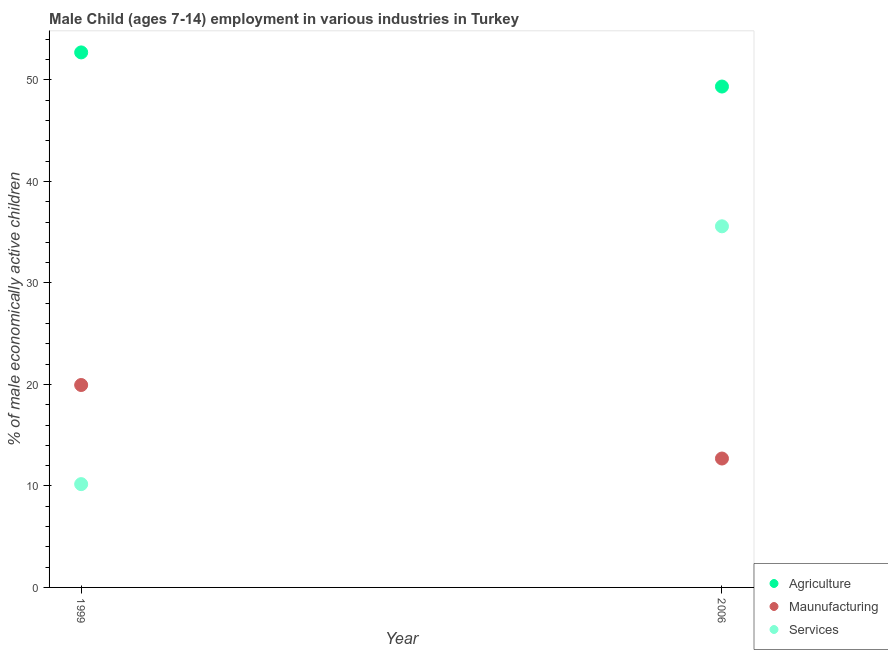How many different coloured dotlines are there?
Make the answer very short. 3. Is the number of dotlines equal to the number of legend labels?
Your answer should be compact. Yes. What is the percentage of economically active children in manufacturing in 1999?
Ensure brevity in your answer.  19.94. Across all years, what is the maximum percentage of economically active children in manufacturing?
Give a very brief answer. 19.94. Across all years, what is the minimum percentage of economically active children in agriculture?
Provide a succinct answer. 49.35. In which year was the percentage of economically active children in services maximum?
Your answer should be compact. 2006. What is the total percentage of economically active children in services in the graph?
Your answer should be very brief. 45.76. What is the difference between the percentage of economically active children in services in 1999 and that in 2006?
Make the answer very short. -25.4. What is the difference between the percentage of economically active children in manufacturing in 2006 and the percentage of economically active children in agriculture in 1999?
Give a very brief answer. -40.01. What is the average percentage of economically active children in services per year?
Your answer should be very brief. 22.88. In the year 2006, what is the difference between the percentage of economically active children in manufacturing and percentage of economically active children in agriculture?
Ensure brevity in your answer.  -36.65. In how many years, is the percentage of economically active children in services greater than 2 %?
Offer a very short reply. 2. What is the ratio of the percentage of economically active children in services in 1999 to that in 2006?
Ensure brevity in your answer.  0.29. Is it the case that in every year, the sum of the percentage of economically active children in agriculture and percentage of economically active children in manufacturing is greater than the percentage of economically active children in services?
Provide a succinct answer. Yes. Is the percentage of economically active children in manufacturing strictly greater than the percentage of economically active children in services over the years?
Offer a very short reply. No. Is the percentage of economically active children in agriculture strictly less than the percentage of economically active children in manufacturing over the years?
Provide a short and direct response. No. How many years are there in the graph?
Your answer should be very brief. 2. Are the values on the major ticks of Y-axis written in scientific E-notation?
Offer a terse response. No. Does the graph contain any zero values?
Give a very brief answer. No. Where does the legend appear in the graph?
Your response must be concise. Bottom right. What is the title of the graph?
Offer a very short reply. Male Child (ages 7-14) employment in various industries in Turkey. What is the label or title of the X-axis?
Give a very brief answer. Year. What is the label or title of the Y-axis?
Offer a very short reply. % of male economically active children. What is the % of male economically active children of Agriculture in 1999?
Make the answer very short. 52.71. What is the % of male economically active children of Maunufacturing in 1999?
Give a very brief answer. 19.94. What is the % of male economically active children of Services in 1999?
Provide a succinct answer. 10.18. What is the % of male economically active children of Agriculture in 2006?
Make the answer very short. 49.35. What is the % of male economically active children of Services in 2006?
Offer a very short reply. 35.58. Across all years, what is the maximum % of male economically active children of Agriculture?
Keep it short and to the point. 52.71. Across all years, what is the maximum % of male economically active children of Maunufacturing?
Ensure brevity in your answer.  19.94. Across all years, what is the maximum % of male economically active children in Services?
Offer a terse response. 35.58. Across all years, what is the minimum % of male economically active children of Agriculture?
Your answer should be compact. 49.35. Across all years, what is the minimum % of male economically active children in Services?
Your answer should be compact. 10.18. What is the total % of male economically active children in Agriculture in the graph?
Give a very brief answer. 102.06. What is the total % of male economically active children in Maunufacturing in the graph?
Provide a succinct answer. 32.64. What is the total % of male economically active children in Services in the graph?
Your answer should be very brief. 45.76. What is the difference between the % of male economically active children of Agriculture in 1999 and that in 2006?
Ensure brevity in your answer.  3.36. What is the difference between the % of male economically active children in Maunufacturing in 1999 and that in 2006?
Provide a short and direct response. 7.24. What is the difference between the % of male economically active children in Services in 1999 and that in 2006?
Offer a terse response. -25.4. What is the difference between the % of male economically active children of Agriculture in 1999 and the % of male economically active children of Maunufacturing in 2006?
Provide a succinct answer. 40.01. What is the difference between the % of male economically active children of Agriculture in 1999 and the % of male economically active children of Services in 2006?
Your answer should be very brief. 17.13. What is the difference between the % of male economically active children of Maunufacturing in 1999 and the % of male economically active children of Services in 2006?
Offer a very short reply. -15.64. What is the average % of male economically active children in Agriculture per year?
Make the answer very short. 51.03. What is the average % of male economically active children of Maunufacturing per year?
Keep it short and to the point. 16.32. What is the average % of male economically active children of Services per year?
Keep it short and to the point. 22.88. In the year 1999, what is the difference between the % of male economically active children in Agriculture and % of male economically active children in Maunufacturing?
Your response must be concise. 32.77. In the year 1999, what is the difference between the % of male economically active children of Agriculture and % of male economically active children of Services?
Your response must be concise. 42.53. In the year 1999, what is the difference between the % of male economically active children of Maunufacturing and % of male economically active children of Services?
Offer a very short reply. 9.77. In the year 2006, what is the difference between the % of male economically active children in Agriculture and % of male economically active children in Maunufacturing?
Offer a terse response. 36.65. In the year 2006, what is the difference between the % of male economically active children of Agriculture and % of male economically active children of Services?
Provide a short and direct response. 13.77. In the year 2006, what is the difference between the % of male economically active children of Maunufacturing and % of male economically active children of Services?
Provide a short and direct response. -22.88. What is the ratio of the % of male economically active children in Agriculture in 1999 to that in 2006?
Keep it short and to the point. 1.07. What is the ratio of the % of male economically active children in Maunufacturing in 1999 to that in 2006?
Give a very brief answer. 1.57. What is the ratio of the % of male economically active children in Services in 1999 to that in 2006?
Give a very brief answer. 0.29. What is the difference between the highest and the second highest % of male economically active children of Agriculture?
Provide a succinct answer. 3.36. What is the difference between the highest and the second highest % of male economically active children of Maunufacturing?
Offer a terse response. 7.24. What is the difference between the highest and the second highest % of male economically active children in Services?
Keep it short and to the point. 25.4. What is the difference between the highest and the lowest % of male economically active children of Agriculture?
Your answer should be very brief. 3.36. What is the difference between the highest and the lowest % of male economically active children of Maunufacturing?
Offer a terse response. 7.24. What is the difference between the highest and the lowest % of male economically active children of Services?
Your answer should be very brief. 25.4. 